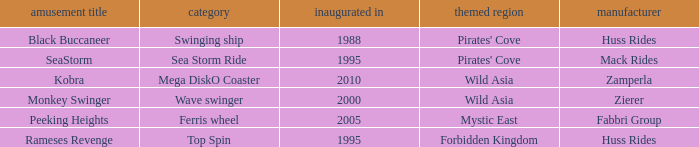What type of ride was built by the company zierer? Monkey Swinger. 